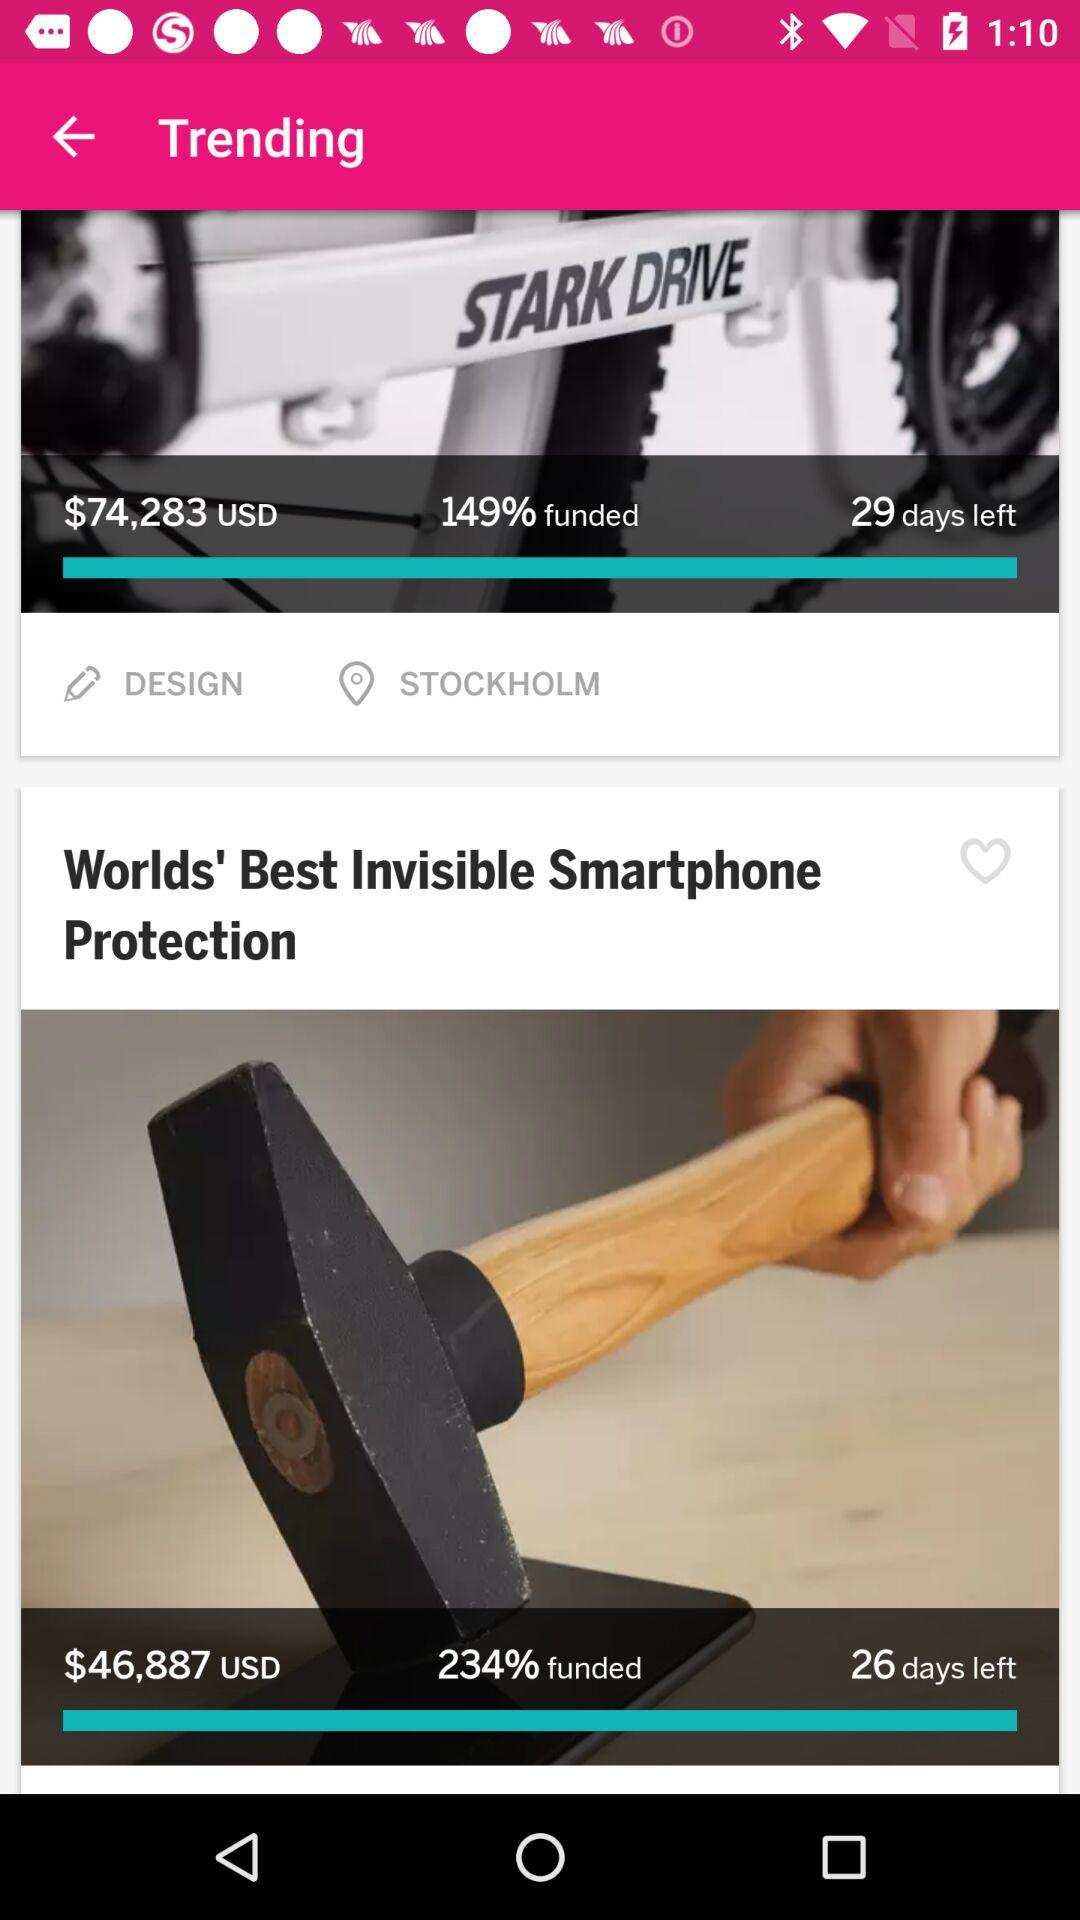What is the location? The location is Stockholm. 